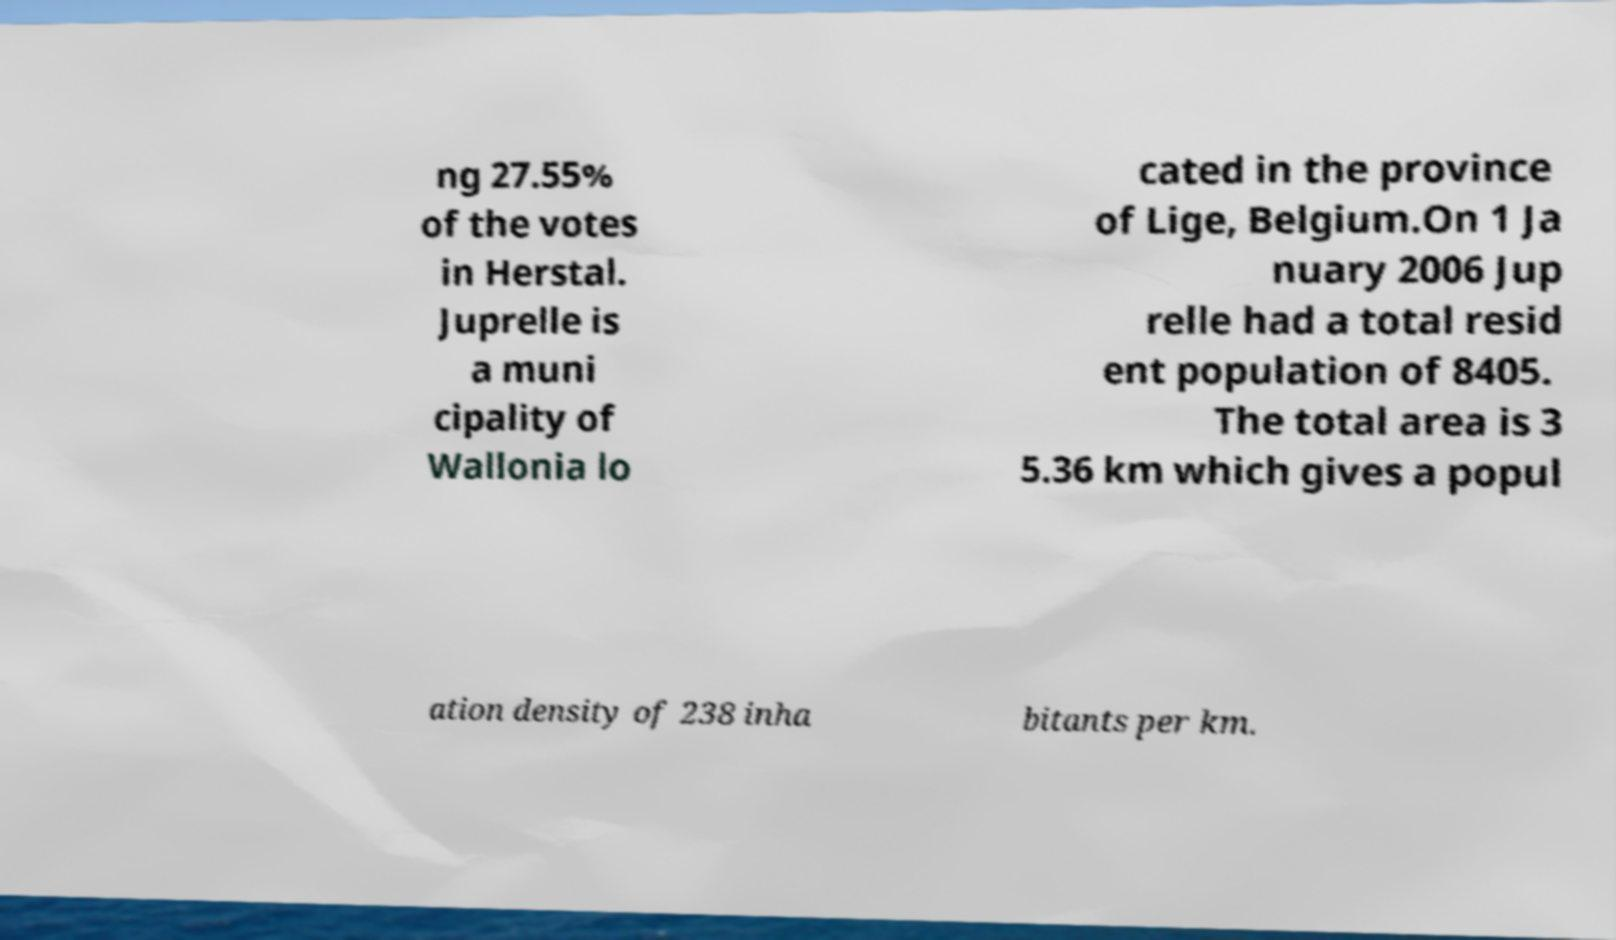Please identify and transcribe the text found in this image. ng 27.55% of the votes in Herstal. Juprelle is a muni cipality of Wallonia lo cated in the province of Lige, Belgium.On 1 Ja nuary 2006 Jup relle had a total resid ent population of 8405. The total area is 3 5.36 km which gives a popul ation density of 238 inha bitants per km. 